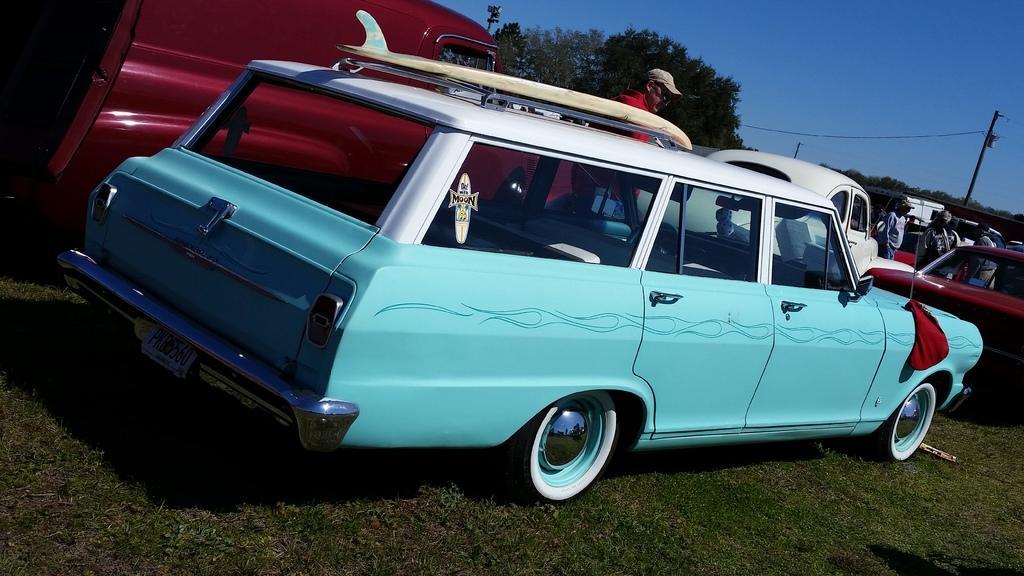Could you give a brief overview of what you see in this image? In this picture I can see vehicles, there are group of people standing, there are poles, trees, and in the background there is sky. 